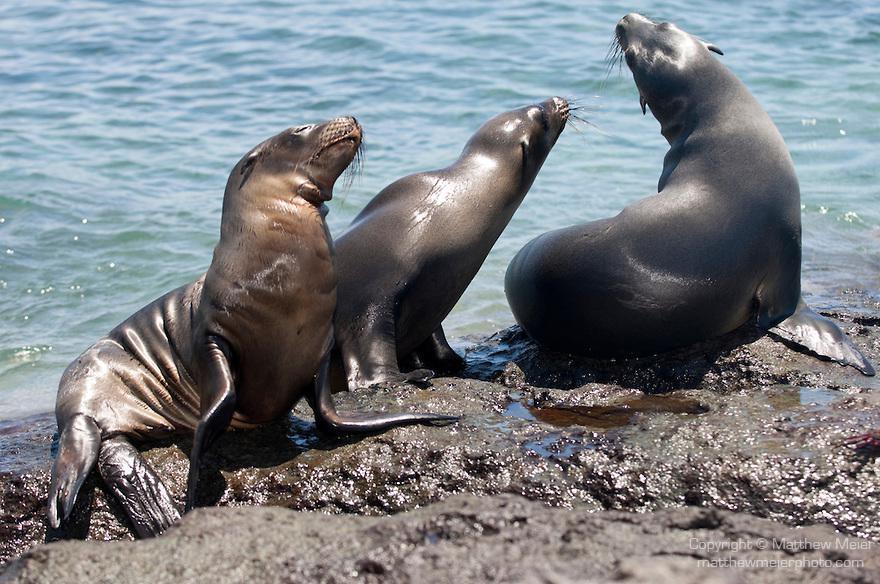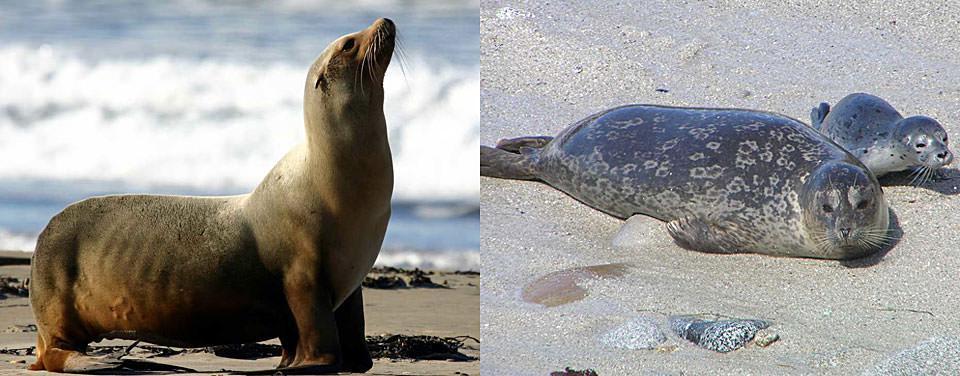The first image is the image on the left, the second image is the image on the right. Assess this claim about the two images: "The right image contains no more than one seal.". Correct or not? Answer yes or no. No. The first image is the image on the left, the second image is the image on the right. For the images shown, is this caption "A seal is catching a fish." true? Answer yes or no. No. 